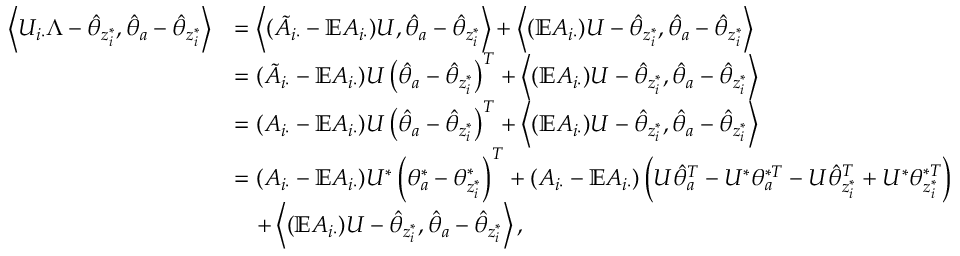<formula> <loc_0><loc_0><loc_500><loc_500>\begin{array} { r l } { \left \langle U _ { i \cdot } \Lambda - \hat { \theta } _ { z _ { i } ^ { * } } , \hat { \theta } _ { a } - \hat { \theta } _ { z _ { i } ^ { * } } \right \rangle } & { = \left \langle ( \tilde { A } _ { i \cdot } - \mathbb { E } A _ { i \cdot } ) U , \hat { \theta } _ { a } - \hat { \theta } _ { z _ { i } ^ { * } } \right \rangle + \left \langle ( \mathbb { E } A _ { i \cdot } ) U - \hat { \theta } _ { z _ { i } ^ { * } } , \hat { \theta } _ { a } - \hat { \theta } _ { z _ { i } ^ { * } } \right \rangle } \\ & { = ( \tilde { A } _ { i \cdot } - \mathbb { E } A _ { i \cdot } ) U \left ( \hat { \theta } _ { a } - \hat { \theta } _ { z _ { i } ^ { * } } \right ) ^ { T } + \left \langle ( \mathbb { E } A _ { i \cdot } ) U - \hat { \theta } _ { z _ { i } ^ { * } } , \hat { \theta } _ { a } - \hat { \theta } _ { z _ { i } ^ { * } } \right \rangle } \\ & { = ( A _ { i \cdot } - \mathbb { E } A _ { i \cdot } ) U \left ( \hat { \theta } _ { a } - \hat { \theta } _ { z _ { i } ^ { * } } \right ) ^ { T } + \left \langle ( \mathbb { E } A _ { i \cdot } ) U - \hat { \theta } _ { z _ { i } ^ { * } } , \hat { \theta } _ { a } - \hat { \theta } _ { z _ { i } ^ { * } } \right \rangle } \\ & { = ( A _ { i \cdot } - \mathbb { E } A _ { i \cdot } ) U ^ { * } \left ( \theta _ { a } ^ { * } - \theta _ { z _ { i } ^ { * } } ^ { * } \right ) ^ { T } + ( A _ { i \cdot } - \mathbb { E } A _ { i \cdot } ) \left ( U \hat { \theta } _ { a } ^ { T } - U ^ { * } \theta _ { a } ^ { * T } - U \hat { \theta } _ { z _ { i } ^ { * } } ^ { T } + U ^ { * } \theta _ { z _ { i } ^ { * } } ^ { * T } \right ) } \\ & { \quad + \left \langle ( \mathbb { E } A _ { i \cdot } ) U - \hat { \theta } _ { z _ { i } ^ { * } } , \hat { \theta } _ { a } - \hat { \theta } _ { z _ { i } ^ { * } } \right \rangle , } \end{array}</formula> 